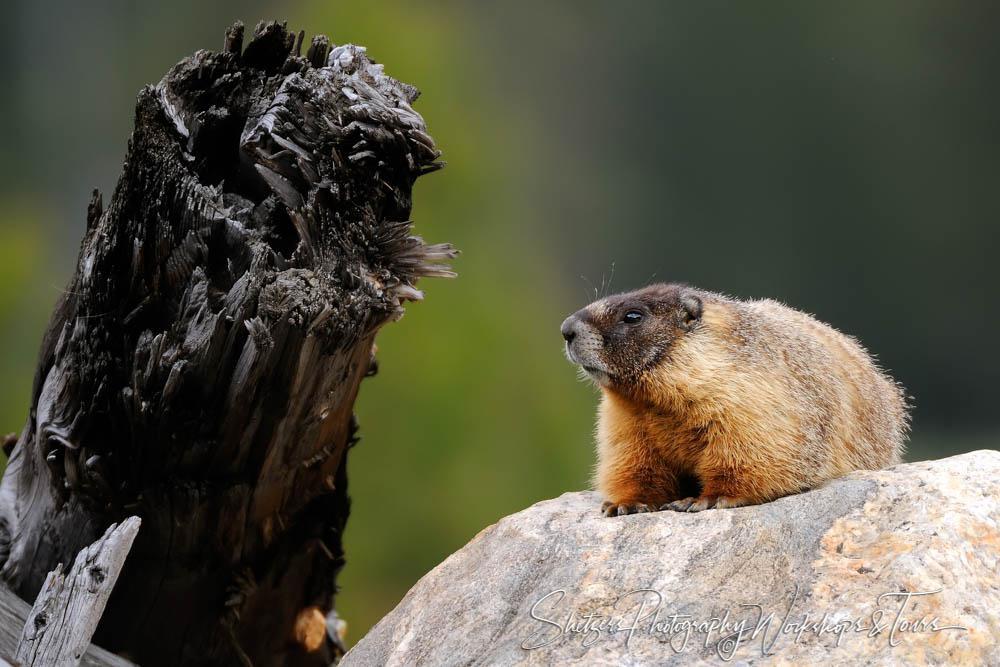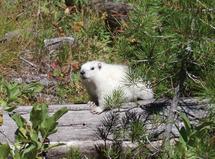The first image is the image on the left, the second image is the image on the right. For the images displayed, is the sentence "The right image contains one small animal facing leftward, with its body flat on a rock and its brown tail angled downward." factually correct? Answer yes or no. No. 